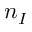Convert formula to latex. <formula><loc_0><loc_0><loc_500><loc_500>n _ { I }</formula> 